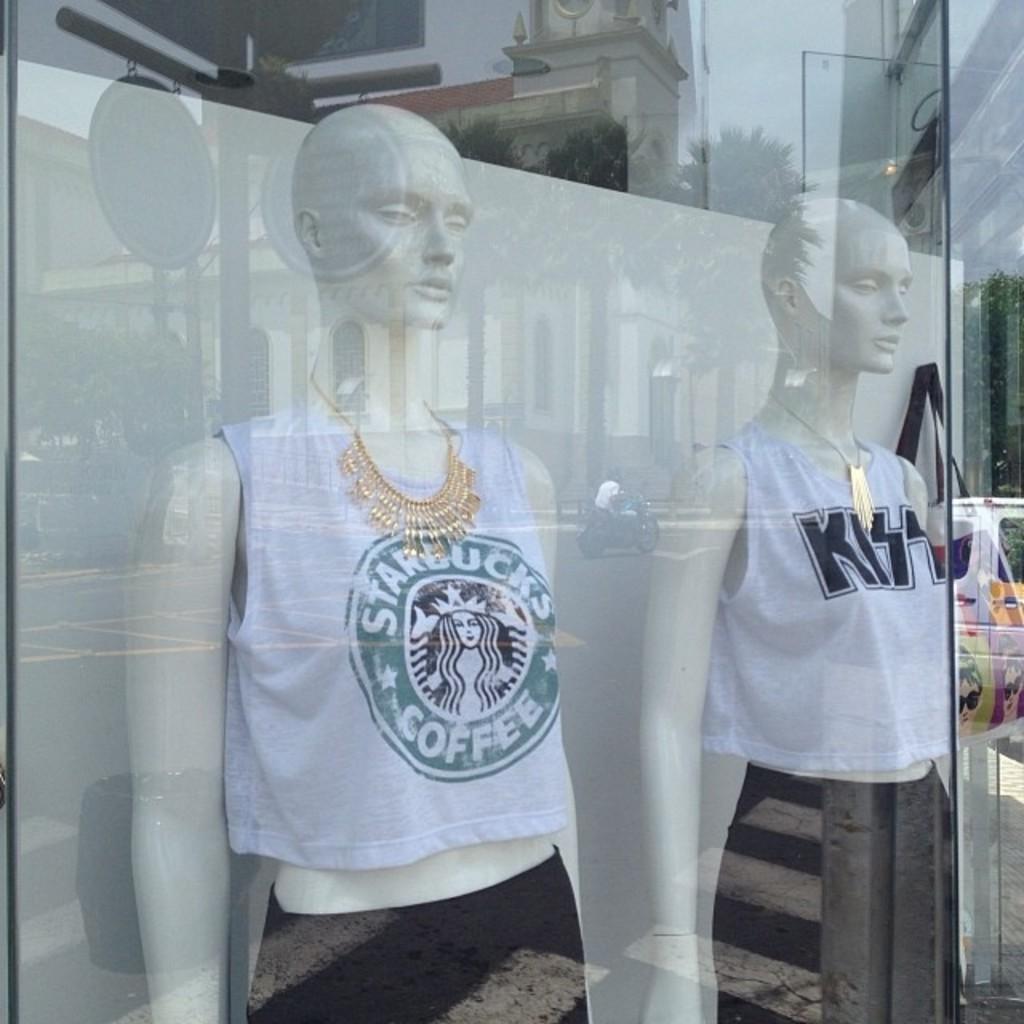What coffee shop is on the first t-shirt?
Your response must be concise. Starbucks. 